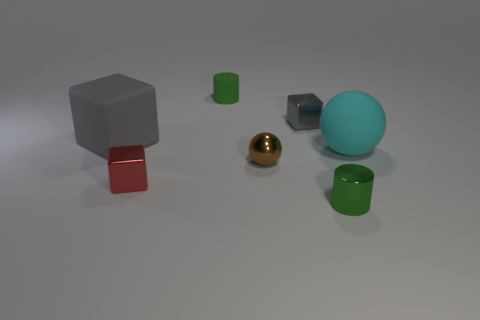What is the shape of the gray metallic object that is the same size as the brown shiny ball? cube 